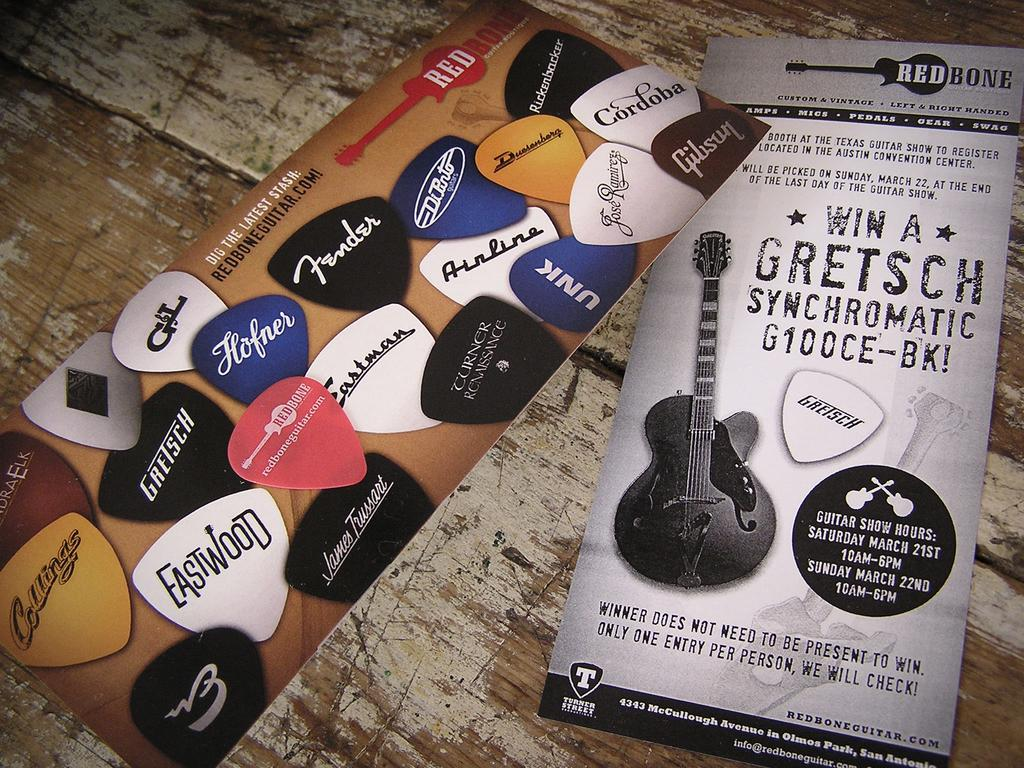What type of surface is visible in the image? There is a wooden surface in the image. What is placed on the wooden surface? There are posters on the wooden surface. What can be seen on the posters? The posters contain images and text. What type of wool is used to create the shape in the image? There is no wool or shape present in the image; it features a wooden surface with posters containing images and text. 